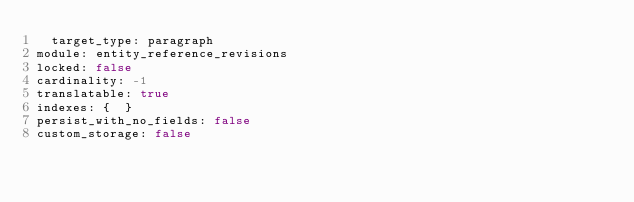<code> <loc_0><loc_0><loc_500><loc_500><_YAML_>  target_type: paragraph
module: entity_reference_revisions
locked: false
cardinality: -1
translatable: true
indexes: {  }
persist_with_no_fields: false
custom_storage: false
</code> 